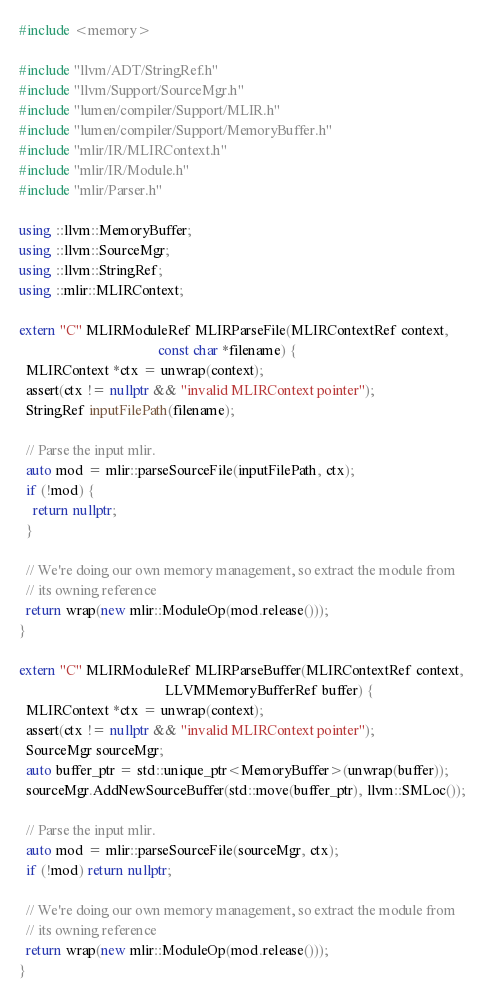<code> <loc_0><loc_0><loc_500><loc_500><_C++_>#include <memory>

#include "llvm/ADT/StringRef.h"
#include "llvm/Support/SourceMgr.h"
#include "lumen/compiler/Support/MLIR.h"
#include "lumen/compiler/Support/MemoryBuffer.h"
#include "mlir/IR/MLIRContext.h"
#include "mlir/IR/Module.h"
#include "mlir/Parser.h"

using ::llvm::MemoryBuffer;
using ::llvm::SourceMgr;
using ::llvm::StringRef;
using ::mlir::MLIRContext;

extern "C" MLIRModuleRef MLIRParseFile(MLIRContextRef context,
                                       const char *filename) {
  MLIRContext *ctx = unwrap(context);
  assert(ctx != nullptr && "invalid MLIRContext pointer");
  StringRef inputFilePath(filename);

  // Parse the input mlir.
  auto mod = mlir::parseSourceFile(inputFilePath, ctx);
  if (!mod) {
    return nullptr;
  }

  // We're doing our own memory management, so extract the module from
  // its owning reference
  return wrap(new mlir::ModuleOp(mod.release()));
}

extern "C" MLIRModuleRef MLIRParseBuffer(MLIRContextRef context,
                                         LLVMMemoryBufferRef buffer) {
  MLIRContext *ctx = unwrap(context);
  assert(ctx != nullptr && "invalid MLIRContext pointer");
  SourceMgr sourceMgr;
  auto buffer_ptr = std::unique_ptr<MemoryBuffer>(unwrap(buffer));
  sourceMgr.AddNewSourceBuffer(std::move(buffer_ptr), llvm::SMLoc());

  // Parse the input mlir.
  auto mod = mlir::parseSourceFile(sourceMgr, ctx);
  if (!mod) return nullptr;

  // We're doing our own memory management, so extract the module from
  // its owning reference
  return wrap(new mlir::ModuleOp(mod.release()));
}
</code> 